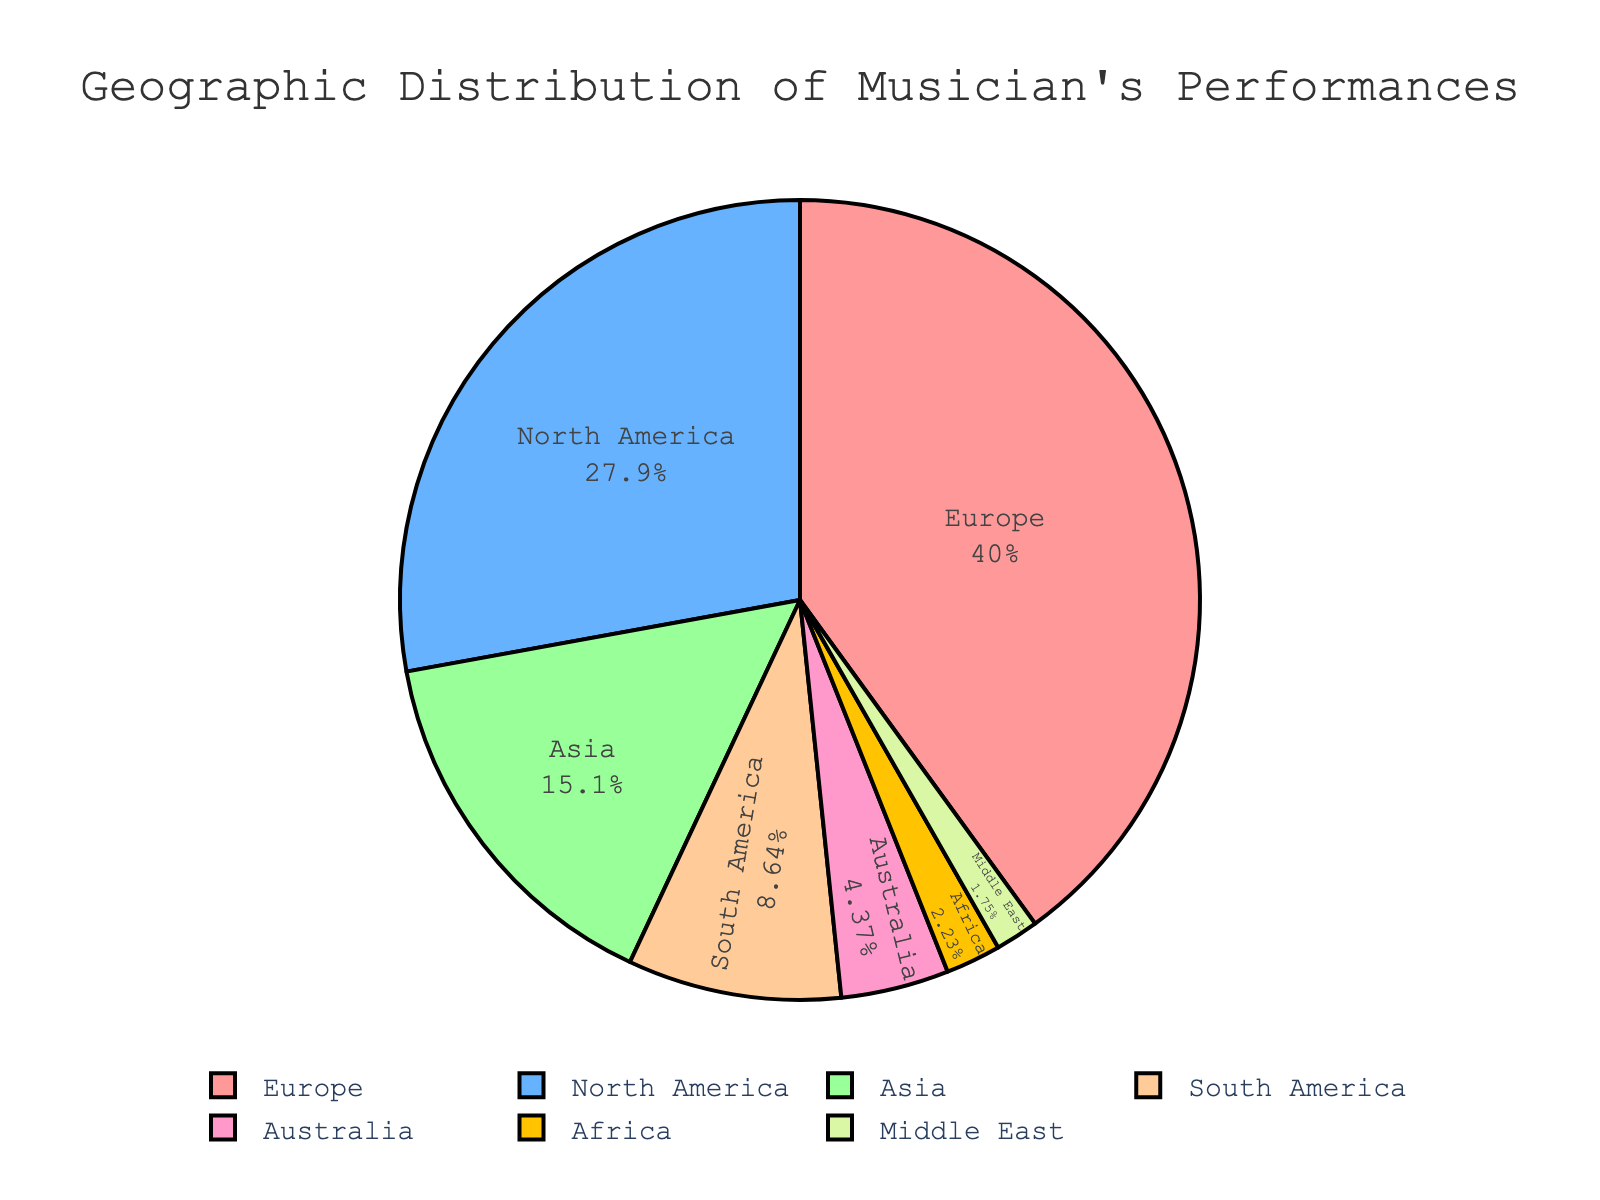What percentage of the musician's performances were in Europe? By looking at the pie chart, we can see that Europe is represented with a portion of the pie and labeled with a percentage. This label will directly tell us the percentage of performances in Europe.
Answer: 41.2% Which continent had the fewest performances? By examining the pie chart, we can identify the continent shown in the smallest segment, which will have the fewest performances.
Answer: Middle East How many more performances were in North America than in Asia? First, find the number of performances in North America (287) and Asia (156). Subtract the number in Asia from the number in North America: 287 - 156.
Answer: 131 If you combined the performances in South America and Australia, what percentage of the total would this account for? Add the number of performances in South America (89) and Australia (45) to get 134. Then calculate the total number of performances by summing all the performances and find the percentage: (134 / (412 + 287 + 156 + 89 + 45 + 23 + 18)) * 100 = (134 / 1030) * 100.
Answer: 13% Are there more performances in Africa and the Middle East combined than in Australia alone? Add the performances in Africa (23) and the Middle East (18) to get a total of 41. Compare this with the number of performances in Australia (45). 41 < 45, so the answer is no.
Answer: No What percentage of the total performances occurred outside Europe and North America? First, find the total number of performances outside Europe (412) and North America (287) by adding the rest: 156 + 89 + 45 + 23 + 18 = 331. Then calculate the percentage of this against the total number of performances: (331 / 1030) * 100.
Answer: 32.1% Which continents have almost the same number of performances? By visually examining the pie chart, we can compare segments of similar size. In this case, Asia (156) and South America (89) have differing numbers, but Australia (45) and Africa (23) are closer, although not equal. The closest match can be found by looking for similar-sized segments.
Answer: Australia and Africa 